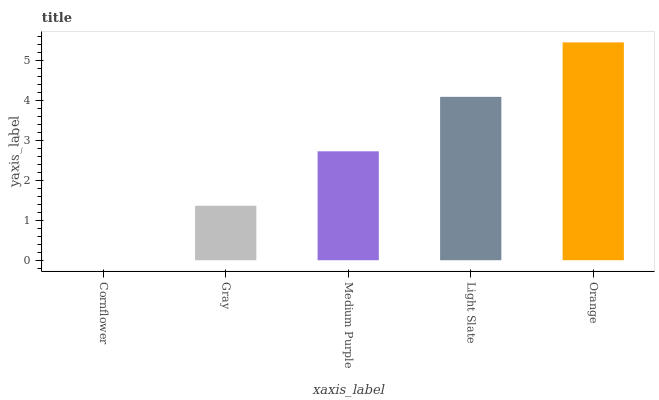Is Cornflower the minimum?
Answer yes or no. Yes. Is Orange the maximum?
Answer yes or no. Yes. Is Gray the minimum?
Answer yes or no. No. Is Gray the maximum?
Answer yes or no. No. Is Gray greater than Cornflower?
Answer yes or no. Yes. Is Cornflower less than Gray?
Answer yes or no. Yes. Is Cornflower greater than Gray?
Answer yes or no. No. Is Gray less than Cornflower?
Answer yes or no. No. Is Medium Purple the high median?
Answer yes or no. Yes. Is Medium Purple the low median?
Answer yes or no. Yes. Is Orange the high median?
Answer yes or no. No. Is Light Slate the low median?
Answer yes or no. No. 